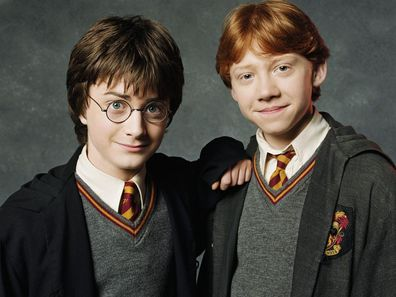Write a creative story with Harry and Ron in a mysterious new place. Harry and Ron stood at the edge of a dense, enchanted forest they had never seen before. The air was thick with magical energy, and the trees whispered secrets in an unknown language. As they ventured deeper, they encountered bizarre creatures - a griffin with shimmering feathers, pixies that danced in the air leaving trails of light, and trees with faces that watched them curiously. Suddenly, they stumbled upon an ancient, deserted castle draped in ivy and mystery. Inside, the walls were adorned with runes and symbols of an ancient magical civilization. In the grand hall, they discovered a large, glowing crystal that seemed to pulsate with raw magical power. As they approached, a spectral figure appeared - the ghost of an ancient wizard who told them of a forgotten prophecy. Harry and Ron needed to unlock the secrets of the crystal to prevent a catastrophic magical event that threatened both the magical and muggle worlds. Thus began their thrilling quest filled with ancient spells, hidden chambers, and the unraveling of a story lost to time. 